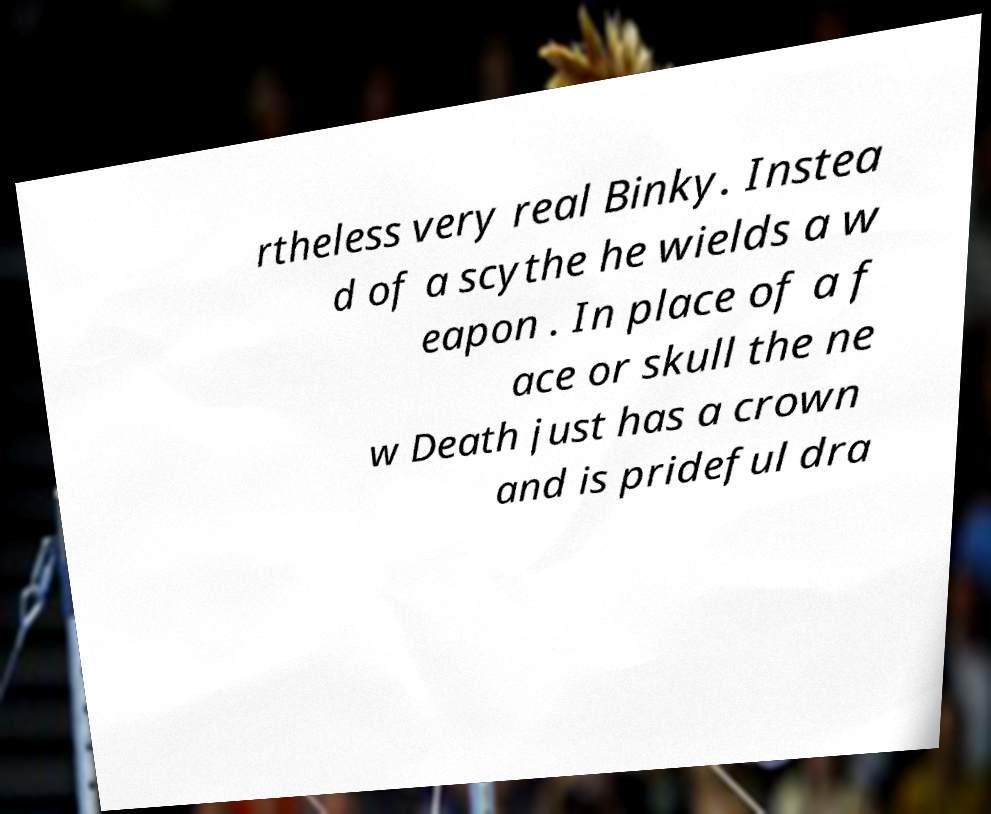For documentation purposes, I need the text within this image transcribed. Could you provide that? rtheless very real Binky. Instea d of a scythe he wields a w eapon . In place of a f ace or skull the ne w Death just has a crown and is prideful dra 